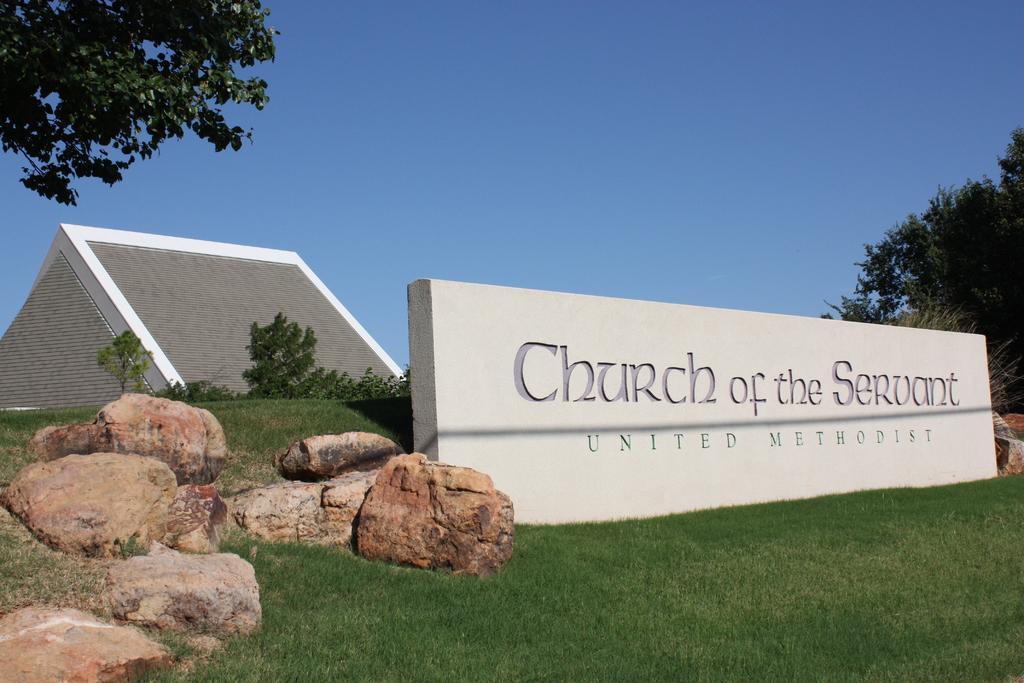How would you summarize this image in a sentence or two? In the center of the image there is a wall. At the bottom of the image there is grass. There are stones to the left side of the image. In the background of the image there is sky and trees. There is pyramid structure. 